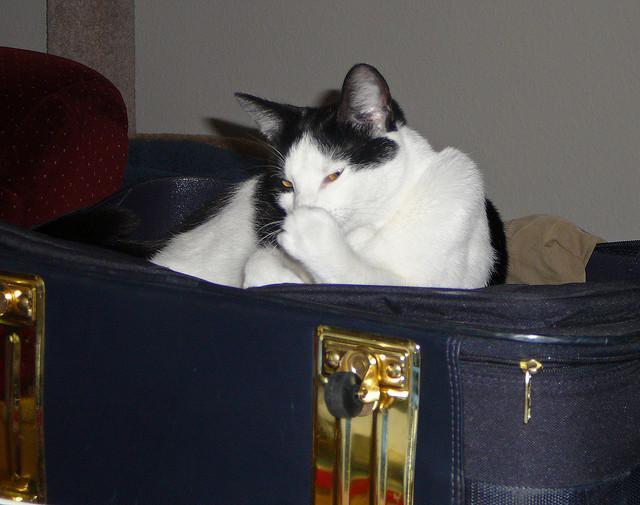How many zebras standing?
Give a very brief answer. 0. 